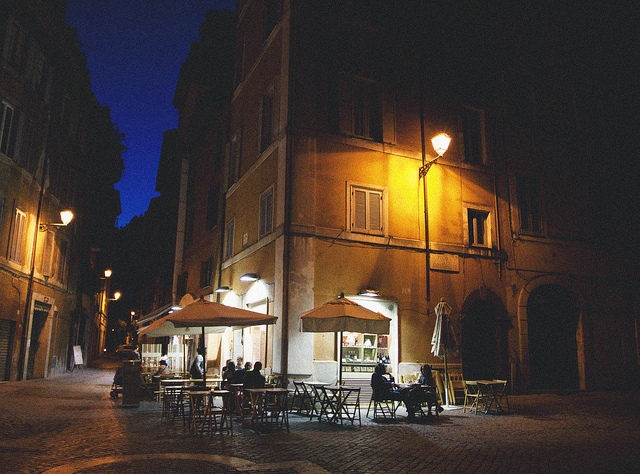<image>What type of boat is seen on far right in background? There is no boat visible in the image. What type of boat is seen on far right in background? I am not sure what type of boat is seen on the far right in the background. It can be either fishing boat or sailboat. 